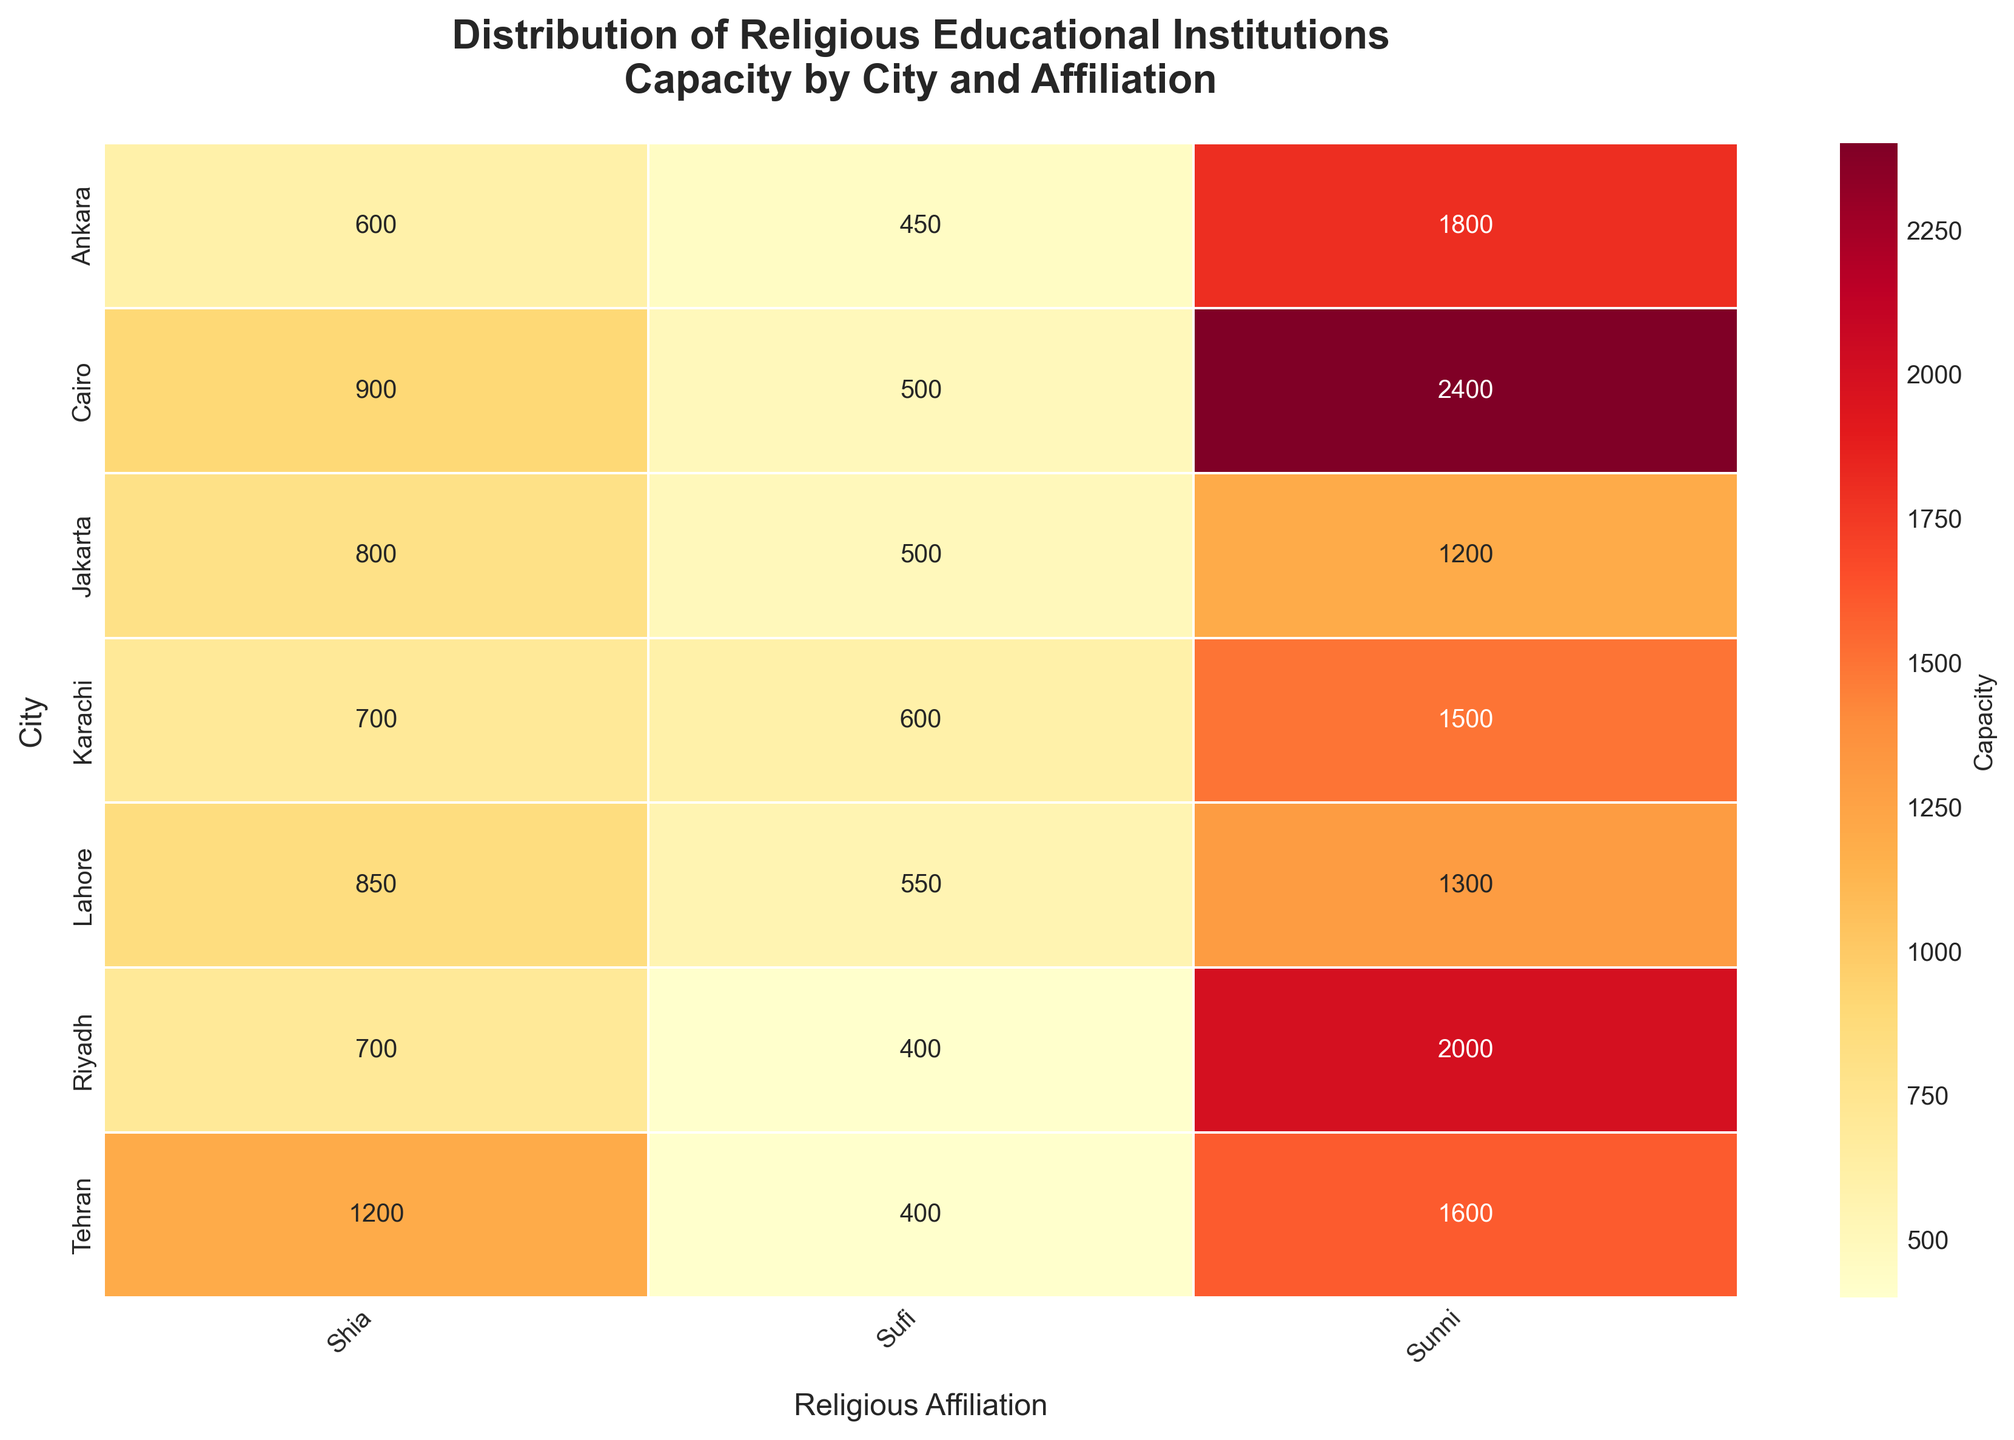What is the total capacity for Sunni-affiliated institutions in Jakarta? To find the total capacity for Sunni-affiliated institutions in Jakarta, simply refer to the cell at the intersection of 'Jakarta' and 'Sunni' and read the value.
Answer: 1200 Which city has the highest capacity for Shia-affiliated institutions and what is the value? Compare the capacities listed under the 'Shia' column across all cities. Identify the city with the highest value.
Answer: Tehran, 1200 What is the sum of the capacities of Sufi-affiliated institutions in Lahore and Karachi? Locate the capacities for Sufi-affiliated institutions in Lahore and Karachi. Sum them up: 550 (Lahore) + 600 (Karachi) = 1150.
Answer: 1150 Which city has the lowest total capacity for religious educational institutions? Sum the capacities for all affiliations for each city and compare to find the lowest total. For example, for Jakarta: 1200 + 800 + 500 = 2500, and similarly for other cities.
Answer: Ankara Between Jakarta and Cairo, which city has a higher capacity for Sufi-affiliated institutions? Compare the values at the intersection of the 'Sufi' column and the rows for 'Jakarta' and 'Cairo': 500 (Jakarta) vs. 500 (Cairo).
Answer: Both have the same capacity, 500 What is the average capacity for Sunni-affiliated institutions across all cities? Sum the capacities for Sunni-affiliated institutions across all cities and divide by the number of cities: (1200 + 1500 + 2400 + 2000 + 1300 + 1800 + 1600) / 7 = 1685.71.
Answer: 1685.71 Which affiliation has the most consistent capacity distribution across the cities? Examine the heatmap for variances in capacities across each affiliation. The affiliation with the least variance in values would be the most consistent.
Answer: Sufi How does the capacity for Shia-affiliated institutions in Riyadh compare to Ankara? Compare the values at the intersection of the 'Shia' column and the rows for 'Riyadh' and 'Ankara': 700 (Riyadh) vs. 600 (Ankara).
Answer: Riyadh is higher What is the difference in capacity between Sunni and Shia-affiliated institutions in Tehran? Subtract the capacity for Shia-affiliated institutions from the capacity for Sunni-affiliated institutions in Tehran: 1600 (Sunni) - 1200 (Shia) = 400.
Answer: 400 What is the total capacity for all types of institutions in Karachi? Sum the capacities for all affiliations in Karachi: 1500 (Sunni) + 700 (Shia) + 600 (Sufi) = 2800.
Answer: 2800 